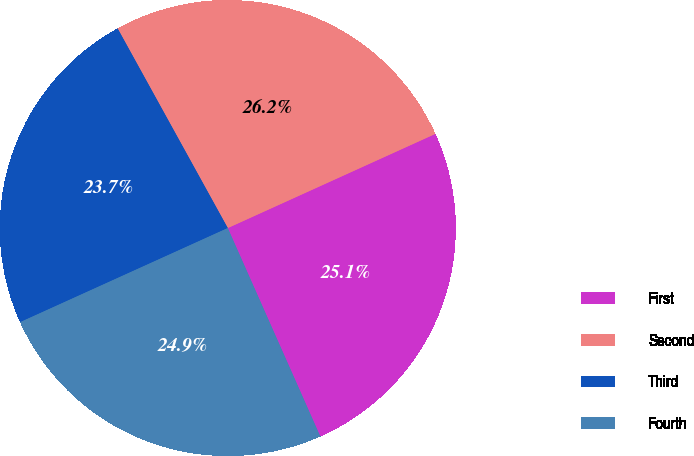Convert chart to OTSL. <chart><loc_0><loc_0><loc_500><loc_500><pie_chart><fcel>First<fcel>Second<fcel>Third<fcel>Fourth<nl><fcel>25.13%<fcel>26.25%<fcel>23.75%<fcel>24.88%<nl></chart> 